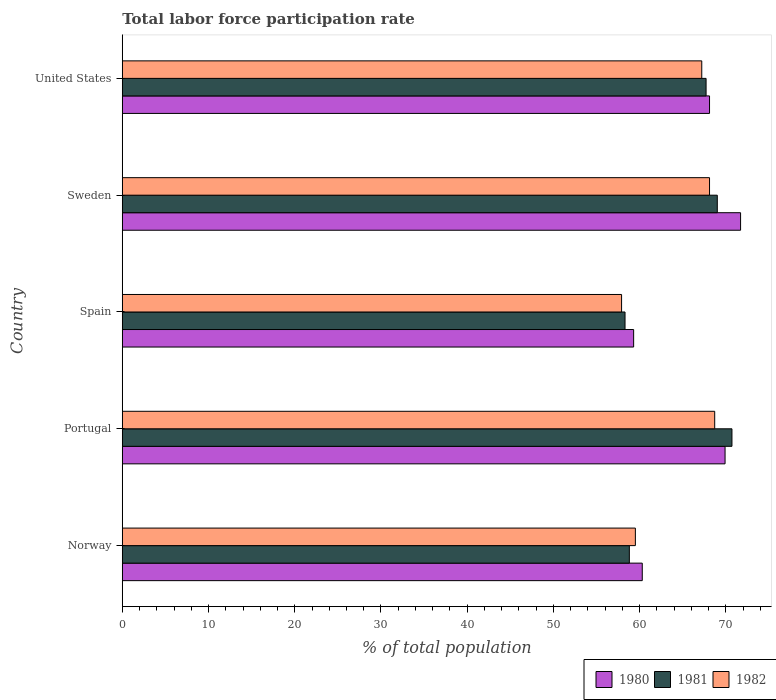How many different coloured bars are there?
Give a very brief answer. 3. How many groups of bars are there?
Ensure brevity in your answer.  5. Are the number of bars per tick equal to the number of legend labels?
Provide a succinct answer. Yes. Are the number of bars on each tick of the Y-axis equal?
Provide a short and direct response. Yes. In how many cases, is the number of bars for a given country not equal to the number of legend labels?
Your response must be concise. 0. What is the total labor force participation rate in 1982 in Norway?
Ensure brevity in your answer.  59.5. Across all countries, what is the maximum total labor force participation rate in 1982?
Your response must be concise. 68.7. Across all countries, what is the minimum total labor force participation rate in 1980?
Offer a terse response. 59.3. In which country was the total labor force participation rate in 1982 maximum?
Provide a succinct answer. Portugal. What is the total total labor force participation rate in 1982 in the graph?
Ensure brevity in your answer.  321.4. What is the difference between the total labor force participation rate in 1980 in Sweden and that in United States?
Keep it short and to the point. 3.6. What is the difference between the total labor force participation rate in 1981 in Spain and the total labor force participation rate in 1982 in United States?
Keep it short and to the point. -8.9. What is the average total labor force participation rate in 1981 per country?
Offer a terse response. 64.9. What is the difference between the total labor force participation rate in 1981 and total labor force participation rate in 1982 in United States?
Offer a very short reply. 0.5. In how many countries, is the total labor force participation rate in 1982 greater than 34 %?
Make the answer very short. 5. What is the ratio of the total labor force participation rate in 1982 in Norway to that in Sweden?
Provide a short and direct response. 0.87. What is the difference between the highest and the second highest total labor force participation rate in 1981?
Your answer should be very brief. 1.7. What is the difference between the highest and the lowest total labor force participation rate in 1980?
Make the answer very short. 12.4. What does the 1st bar from the top in United States represents?
Ensure brevity in your answer.  1982. Are the values on the major ticks of X-axis written in scientific E-notation?
Provide a succinct answer. No. Does the graph contain any zero values?
Your answer should be compact. No. Where does the legend appear in the graph?
Your answer should be compact. Bottom right. What is the title of the graph?
Ensure brevity in your answer.  Total labor force participation rate. Does "2013" appear as one of the legend labels in the graph?
Your answer should be compact. No. What is the label or title of the X-axis?
Your answer should be very brief. % of total population. What is the % of total population in 1980 in Norway?
Give a very brief answer. 60.3. What is the % of total population in 1981 in Norway?
Offer a very short reply. 58.8. What is the % of total population of 1982 in Norway?
Give a very brief answer. 59.5. What is the % of total population in 1980 in Portugal?
Provide a succinct answer. 69.9. What is the % of total population of 1981 in Portugal?
Your answer should be compact. 70.7. What is the % of total population of 1982 in Portugal?
Make the answer very short. 68.7. What is the % of total population in 1980 in Spain?
Your answer should be very brief. 59.3. What is the % of total population in 1981 in Spain?
Your answer should be very brief. 58.3. What is the % of total population of 1982 in Spain?
Your answer should be compact. 57.9. What is the % of total population in 1980 in Sweden?
Offer a very short reply. 71.7. What is the % of total population in 1981 in Sweden?
Your answer should be very brief. 69. What is the % of total population in 1982 in Sweden?
Provide a short and direct response. 68.1. What is the % of total population of 1980 in United States?
Make the answer very short. 68.1. What is the % of total population in 1981 in United States?
Give a very brief answer. 67.7. What is the % of total population in 1982 in United States?
Offer a terse response. 67.2. Across all countries, what is the maximum % of total population of 1980?
Your answer should be very brief. 71.7. Across all countries, what is the maximum % of total population of 1981?
Give a very brief answer. 70.7. Across all countries, what is the maximum % of total population of 1982?
Ensure brevity in your answer.  68.7. Across all countries, what is the minimum % of total population in 1980?
Give a very brief answer. 59.3. Across all countries, what is the minimum % of total population of 1981?
Keep it short and to the point. 58.3. Across all countries, what is the minimum % of total population in 1982?
Ensure brevity in your answer.  57.9. What is the total % of total population of 1980 in the graph?
Provide a short and direct response. 329.3. What is the total % of total population in 1981 in the graph?
Provide a succinct answer. 324.5. What is the total % of total population in 1982 in the graph?
Ensure brevity in your answer.  321.4. What is the difference between the % of total population in 1980 in Norway and that in Portugal?
Offer a terse response. -9.6. What is the difference between the % of total population in 1982 in Norway and that in Portugal?
Offer a terse response. -9.2. What is the difference between the % of total population in 1981 in Norway and that in Spain?
Provide a short and direct response. 0.5. What is the difference between the % of total population of 1982 in Norway and that in Spain?
Provide a succinct answer. 1.6. What is the difference between the % of total population of 1980 in Norway and that in United States?
Make the answer very short. -7.8. What is the difference between the % of total population in 1981 in Norway and that in United States?
Give a very brief answer. -8.9. What is the difference between the % of total population of 1982 in Norway and that in United States?
Offer a terse response. -7.7. What is the difference between the % of total population in 1982 in Portugal and that in Spain?
Give a very brief answer. 10.8. What is the difference between the % of total population in 1980 in Portugal and that in Sweden?
Your answer should be compact. -1.8. What is the difference between the % of total population in 1981 in Portugal and that in United States?
Keep it short and to the point. 3. What is the difference between the % of total population of 1982 in Portugal and that in United States?
Make the answer very short. 1.5. What is the difference between the % of total population of 1980 in Spain and that in Sweden?
Make the answer very short. -12.4. What is the difference between the % of total population of 1982 in Spain and that in Sweden?
Offer a very short reply. -10.2. What is the difference between the % of total population of 1980 in Spain and that in United States?
Keep it short and to the point. -8.8. What is the difference between the % of total population of 1982 in Spain and that in United States?
Ensure brevity in your answer.  -9.3. What is the difference between the % of total population of 1980 in Sweden and that in United States?
Offer a very short reply. 3.6. What is the difference between the % of total population in 1981 in Sweden and that in United States?
Your answer should be very brief. 1.3. What is the difference between the % of total population in 1982 in Sweden and that in United States?
Offer a very short reply. 0.9. What is the difference between the % of total population of 1980 in Norway and the % of total population of 1981 in Portugal?
Ensure brevity in your answer.  -10.4. What is the difference between the % of total population in 1980 in Norway and the % of total population in 1982 in Portugal?
Your answer should be very brief. -8.4. What is the difference between the % of total population of 1981 in Norway and the % of total population of 1982 in Portugal?
Your response must be concise. -9.9. What is the difference between the % of total population of 1980 in Norway and the % of total population of 1981 in Spain?
Give a very brief answer. 2. What is the difference between the % of total population in 1980 in Norway and the % of total population in 1982 in Sweden?
Keep it short and to the point. -7.8. What is the difference between the % of total population of 1980 in Portugal and the % of total population of 1982 in Spain?
Your answer should be compact. 12. What is the difference between the % of total population in 1981 in Portugal and the % of total population in 1982 in Sweden?
Ensure brevity in your answer.  2.6. What is the difference between the % of total population of 1980 in Portugal and the % of total population of 1981 in United States?
Your answer should be very brief. 2.2. What is the difference between the % of total population in 1980 in Spain and the % of total population in 1982 in Sweden?
Your response must be concise. -8.8. What is the difference between the % of total population in 1980 in Spain and the % of total population in 1982 in United States?
Keep it short and to the point. -7.9. What is the difference between the % of total population in 1980 in Sweden and the % of total population in 1982 in United States?
Offer a terse response. 4.5. What is the average % of total population of 1980 per country?
Provide a short and direct response. 65.86. What is the average % of total population of 1981 per country?
Your response must be concise. 64.9. What is the average % of total population in 1982 per country?
Provide a succinct answer. 64.28. What is the difference between the % of total population in 1980 and % of total population in 1981 in Norway?
Offer a terse response. 1.5. What is the difference between the % of total population of 1980 and % of total population of 1981 in Portugal?
Your answer should be compact. -0.8. What is the difference between the % of total population in 1980 and % of total population in 1981 in Spain?
Give a very brief answer. 1. What is the difference between the % of total population of 1980 and % of total population of 1982 in Spain?
Keep it short and to the point. 1.4. What is the difference between the % of total population of 1981 and % of total population of 1982 in Spain?
Give a very brief answer. 0.4. What is the difference between the % of total population in 1980 and % of total population in 1981 in Sweden?
Keep it short and to the point. 2.7. What is the difference between the % of total population of 1981 and % of total population of 1982 in United States?
Ensure brevity in your answer.  0.5. What is the ratio of the % of total population of 1980 in Norway to that in Portugal?
Your response must be concise. 0.86. What is the ratio of the % of total population in 1981 in Norway to that in Portugal?
Offer a terse response. 0.83. What is the ratio of the % of total population of 1982 in Norway to that in Portugal?
Offer a very short reply. 0.87. What is the ratio of the % of total population of 1980 in Norway to that in Spain?
Your response must be concise. 1.02. What is the ratio of the % of total population in 1981 in Norway to that in Spain?
Offer a terse response. 1.01. What is the ratio of the % of total population in 1982 in Norway to that in Spain?
Give a very brief answer. 1.03. What is the ratio of the % of total population in 1980 in Norway to that in Sweden?
Provide a succinct answer. 0.84. What is the ratio of the % of total population of 1981 in Norway to that in Sweden?
Your response must be concise. 0.85. What is the ratio of the % of total population of 1982 in Norway to that in Sweden?
Make the answer very short. 0.87. What is the ratio of the % of total population of 1980 in Norway to that in United States?
Your answer should be compact. 0.89. What is the ratio of the % of total population in 1981 in Norway to that in United States?
Ensure brevity in your answer.  0.87. What is the ratio of the % of total population of 1982 in Norway to that in United States?
Provide a succinct answer. 0.89. What is the ratio of the % of total population in 1980 in Portugal to that in Spain?
Provide a short and direct response. 1.18. What is the ratio of the % of total population in 1981 in Portugal to that in Spain?
Your answer should be very brief. 1.21. What is the ratio of the % of total population of 1982 in Portugal to that in Spain?
Your answer should be very brief. 1.19. What is the ratio of the % of total population in 1980 in Portugal to that in Sweden?
Your response must be concise. 0.97. What is the ratio of the % of total population in 1981 in Portugal to that in Sweden?
Provide a succinct answer. 1.02. What is the ratio of the % of total population in 1982 in Portugal to that in Sweden?
Provide a short and direct response. 1.01. What is the ratio of the % of total population of 1980 in Portugal to that in United States?
Your answer should be compact. 1.03. What is the ratio of the % of total population in 1981 in Portugal to that in United States?
Ensure brevity in your answer.  1.04. What is the ratio of the % of total population in 1982 in Portugal to that in United States?
Ensure brevity in your answer.  1.02. What is the ratio of the % of total population in 1980 in Spain to that in Sweden?
Your response must be concise. 0.83. What is the ratio of the % of total population in 1981 in Spain to that in Sweden?
Provide a short and direct response. 0.84. What is the ratio of the % of total population in 1982 in Spain to that in Sweden?
Ensure brevity in your answer.  0.85. What is the ratio of the % of total population in 1980 in Spain to that in United States?
Your response must be concise. 0.87. What is the ratio of the % of total population in 1981 in Spain to that in United States?
Make the answer very short. 0.86. What is the ratio of the % of total population of 1982 in Spain to that in United States?
Keep it short and to the point. 0.86. What is the ratio of the % of total population of 1980 in Sweden to that in United States?
Offer a terse response. 1.05. What is the ratio of the % of total population of 1981 in Sweden to that in United States?
Provide a succinct answer. 1.02. What is the ratio of the % of total population of 1982 in Sweden to that in United States?
Keep it short and to the point. 1.01. What is the difference between the highest and the second highest % of total population in 1981?
Your answer should be very brief. 1.7. What is the difference between the highest and the lowest % of total population of 1982?
Your answer should be compact. 10.8. 